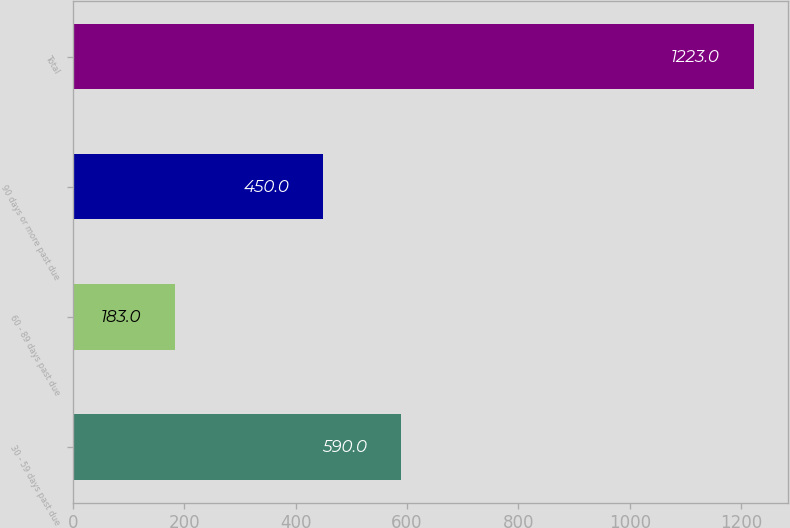<chart> <loc_0><loc_0><loc_500><loc_500><bar_chart><fcel>30 - 59 days past due<fcel>60 - 89 days past due<fcel>90 days or more past due<fcel>Total<nl><fcel>590<fcel>183<fcel>450<fcel>1223<nl></chart> 